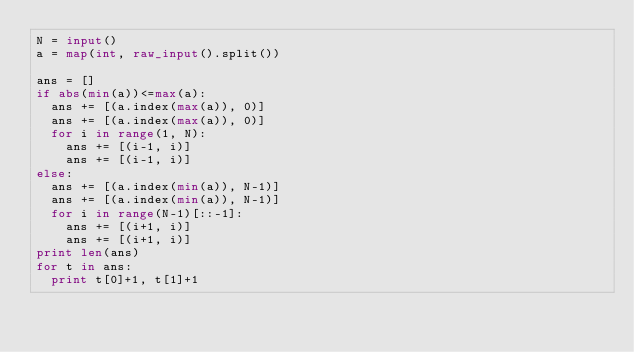<code> <loc_0><loc_0><loc_500><loc_500><_Python_>N = input()
a = map(int, raw_input().split())

ans = []
if abs(min(a))<=max(a):
  ans += [(a.index(max(a)), 0)]
  ans += [(a.index(max(a)), 0)]
  for i in range(1, N):
    ans += [(i-1, i)]
    ans += [(i-1, i)]
else:
  ans += [(a.index(min(a)), N-1)]
  ans += [(a.index(min(a)), N-1)]
  for i in range(N-1)[::-1]:
    ans += [(i+1, i)]
    ans += [(i+1, i)]
print len(ans)
for t in ans:
  print t[0]+1, t[1]+1
</code> 